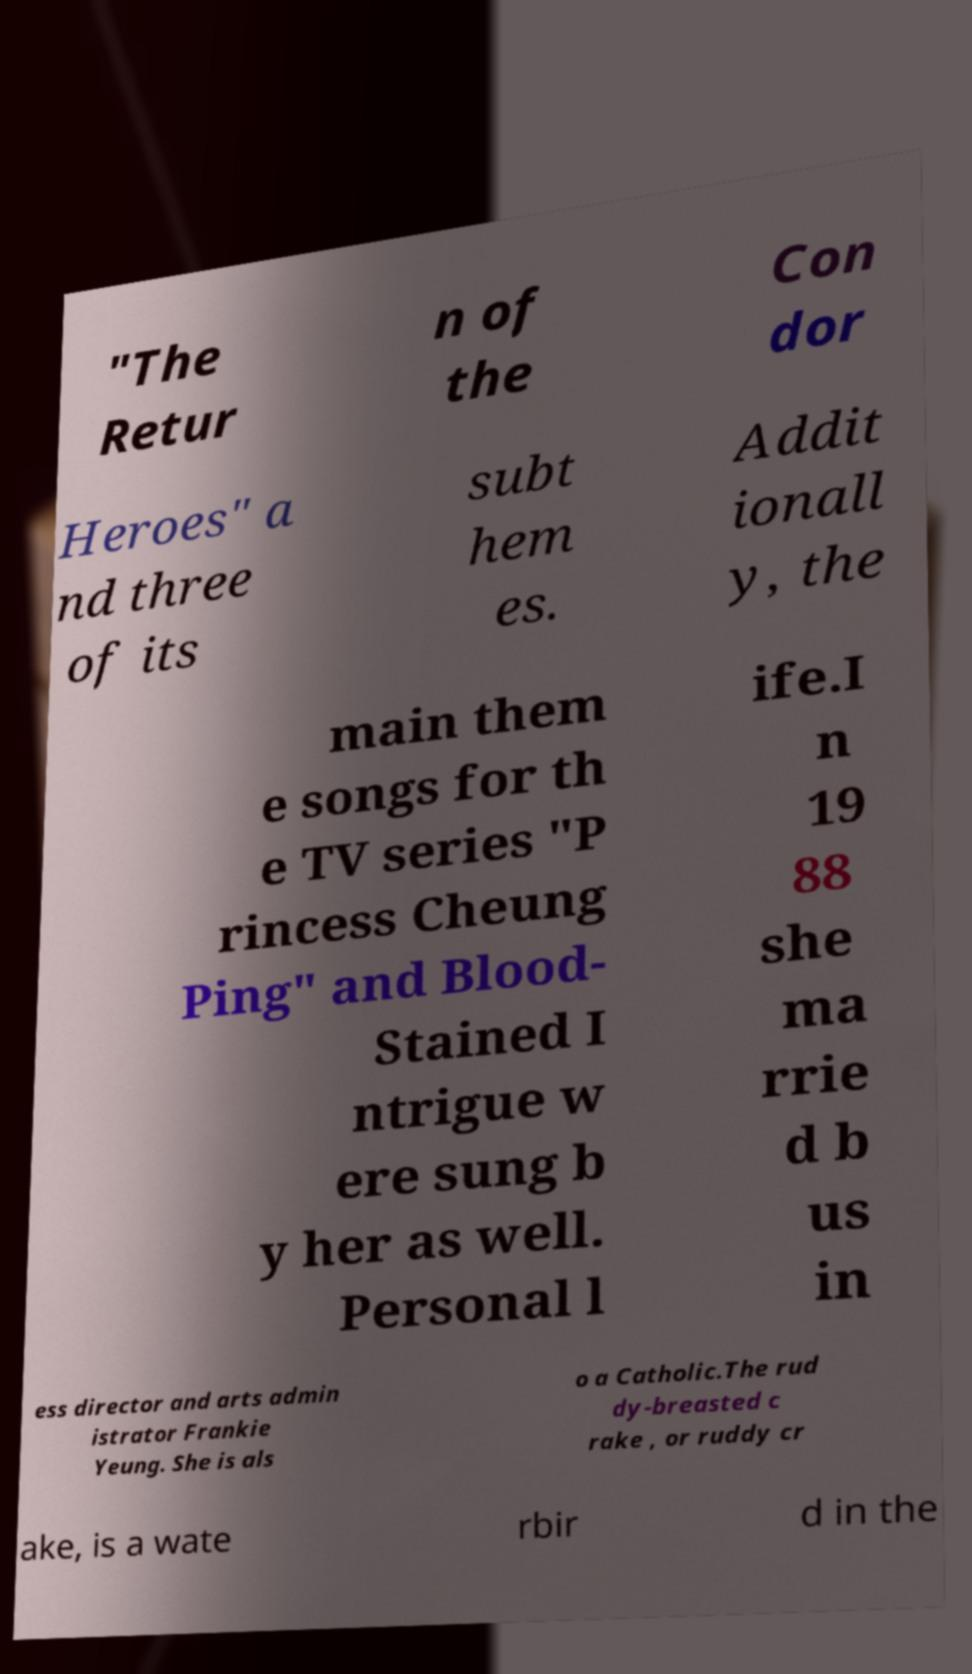Please identify and transcribe the text found in this image. "The Retur n of the Con dor Heroes" a nd three of its subt hem es. Addit ionall y, the main them e songs for th e TV series "P rincess Cheung Ping" and Blood- Stained I ntrigue w ere sung b y her as well. Personal l ife.I n 19 88 she ma rrie d b us in ess director and arts admin istrator Frankie Yeung. She is als o a Catholic.The rud dy-breasted c rake , or ruddy cr ake, is a wate rbir d in the 